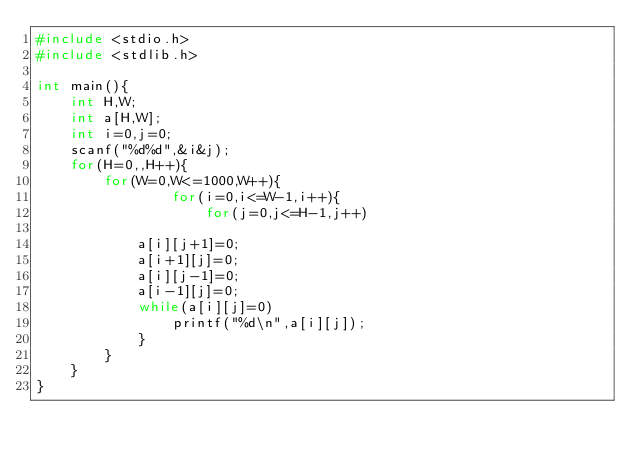Convert code to text. <code><loc_0><loc_0><loc_500><loc_500><_C_>#include <stdio.h>
#include <stdlib.h>

int main(){
    int H,W;
    int a[H,W];
    int i=0,j=0;
    scanf("%d%d",&i&j);
    for(H=0,,H++){
        for(W=0,W<=1000,W++){
                for(i=0,i<=W-1,i++){
                    for(j=0,j<=H-1,j++)
                
            a[i][j+1]=0;
            a[i+1][j]=0;
            a[i][j-1]=0;
            a[i-1][j]=0;
            while(a[i][j]=0)
                printf("%d\n",a[i][j]);
            }
        }
    }
}</code> 